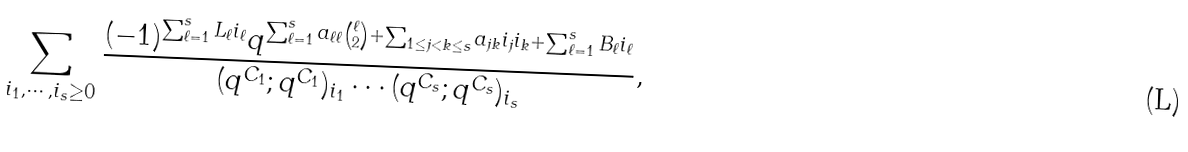Convert formula to latex. <formula><loc_0><loc_0><loc_500><loc_500>\sum _ { i _ { 1 } , \cdots , i _ { s } \geq 0 } \frac { ( - 1 ) ^ { \sum _ { \ell = 1 } ^ { s } L _ { \ell } i _ { \ell } } q ^ { \sum _ { \ell = 1 } ^ { s } a _ { \ell \ell } { \ell \choose 2 } + \sum _ { 1 \leq j < k \leq s } a _ { j k } i _ { j } i _ { k } + \sum _ { \ell = 1 } ^ { s } B _ { \ell } i _ { \ell } } } { ( q ^ { C _ { 1 } } ; q ^ { C _ { 1 } } ) _ { i _ { 1 } } \cdots ( q ^ { C _ { s } } ; q ^ { C _ { s } } ) _ { i _ { s } } } ,</formula> 